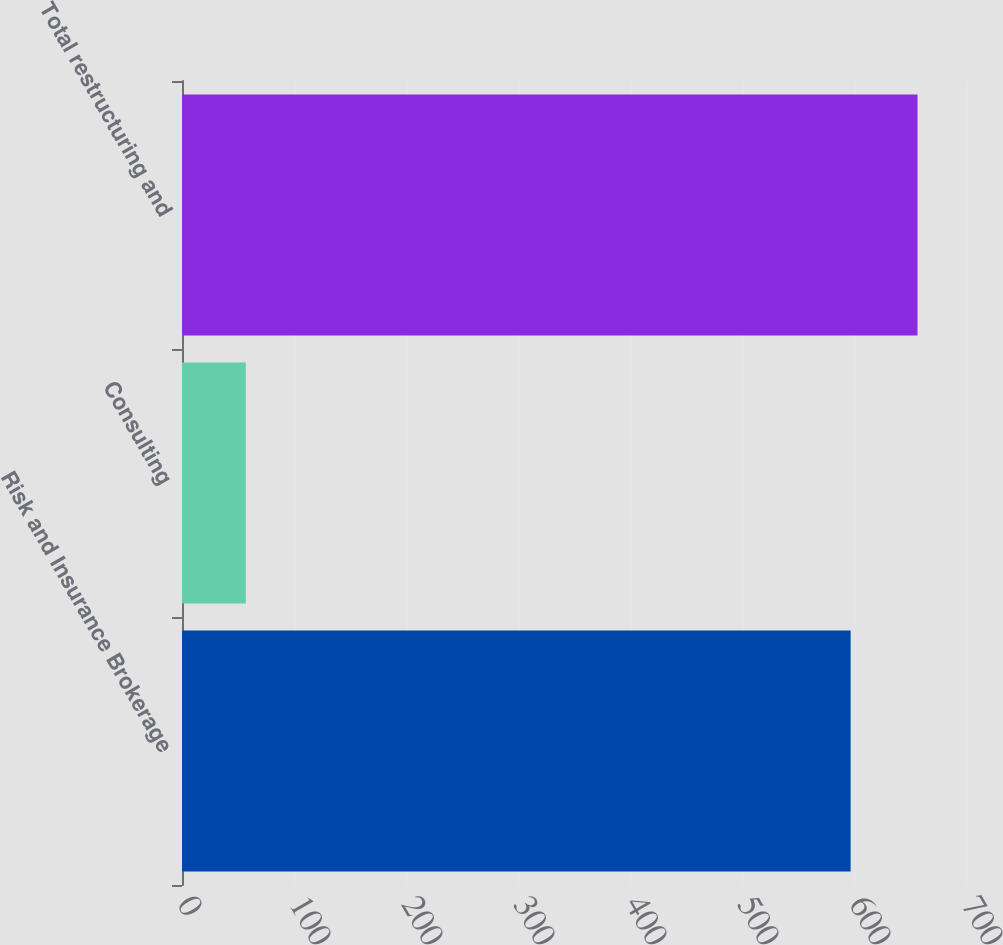Convert chart to OTSL. <chart><loc_0><loc_0><loc_500><loc_500><bar_chart><fcel>Risk and Insurance Brokerage<fcel>Consulting<fcel>Total restructuring and<nl><fcel>597<fcel>57<fcel>656.7<nl></chart> 